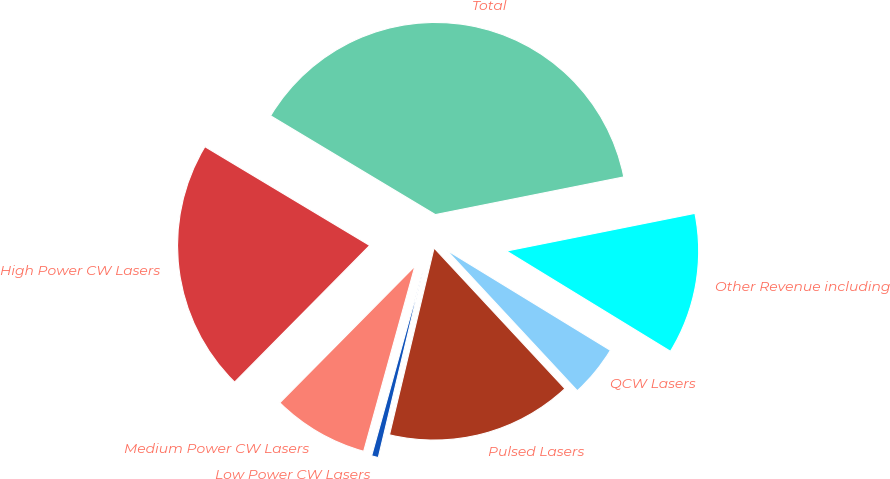Convert chart to OTSL. <chart><loc_0><loc_0><loc_500><loc_500><pie_chart><fcel>High Power CW Lasers<fcel>Medium Power CW Lasers<fcel>Low Power CW Lasers<fcel>Pulsed Lasers<fcel>QCW Lasers<fcel>Other Revenue including<fcel>Total<nl><fcel>21.19%<fcel>8.11%<fcel>0.57%<fcel>15.65%<fcel>4.34%<fcel>11.88%<fcel>38.26%<nl></chart> 